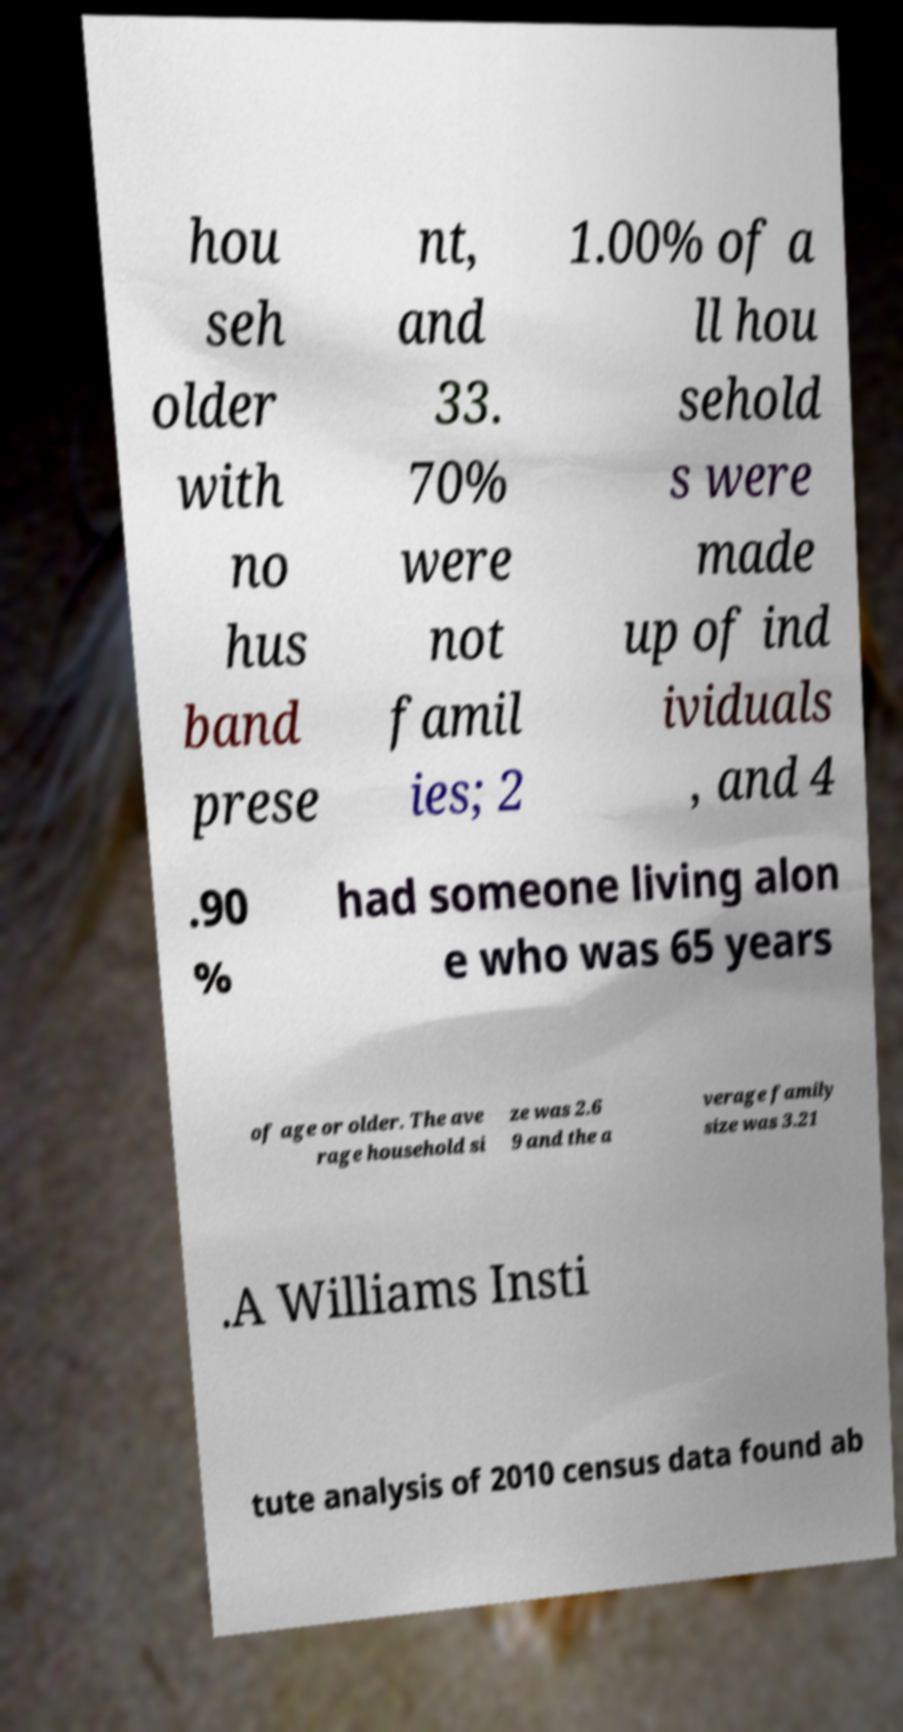Please identify and transcribe the text found in this image. hou seh older with no hus band prese nt, and 33. 70% were not famil ies; 2 1.00% of a ll hou sehold s were made up of ind ividuals , and 4 .90 % had someone living alon e who was 65 years of age or older. The ave rage household si ze was 2.6 9 and the a verage family size was 3.21 .A Williams Insti tute analysis of 2010 census data found ab 